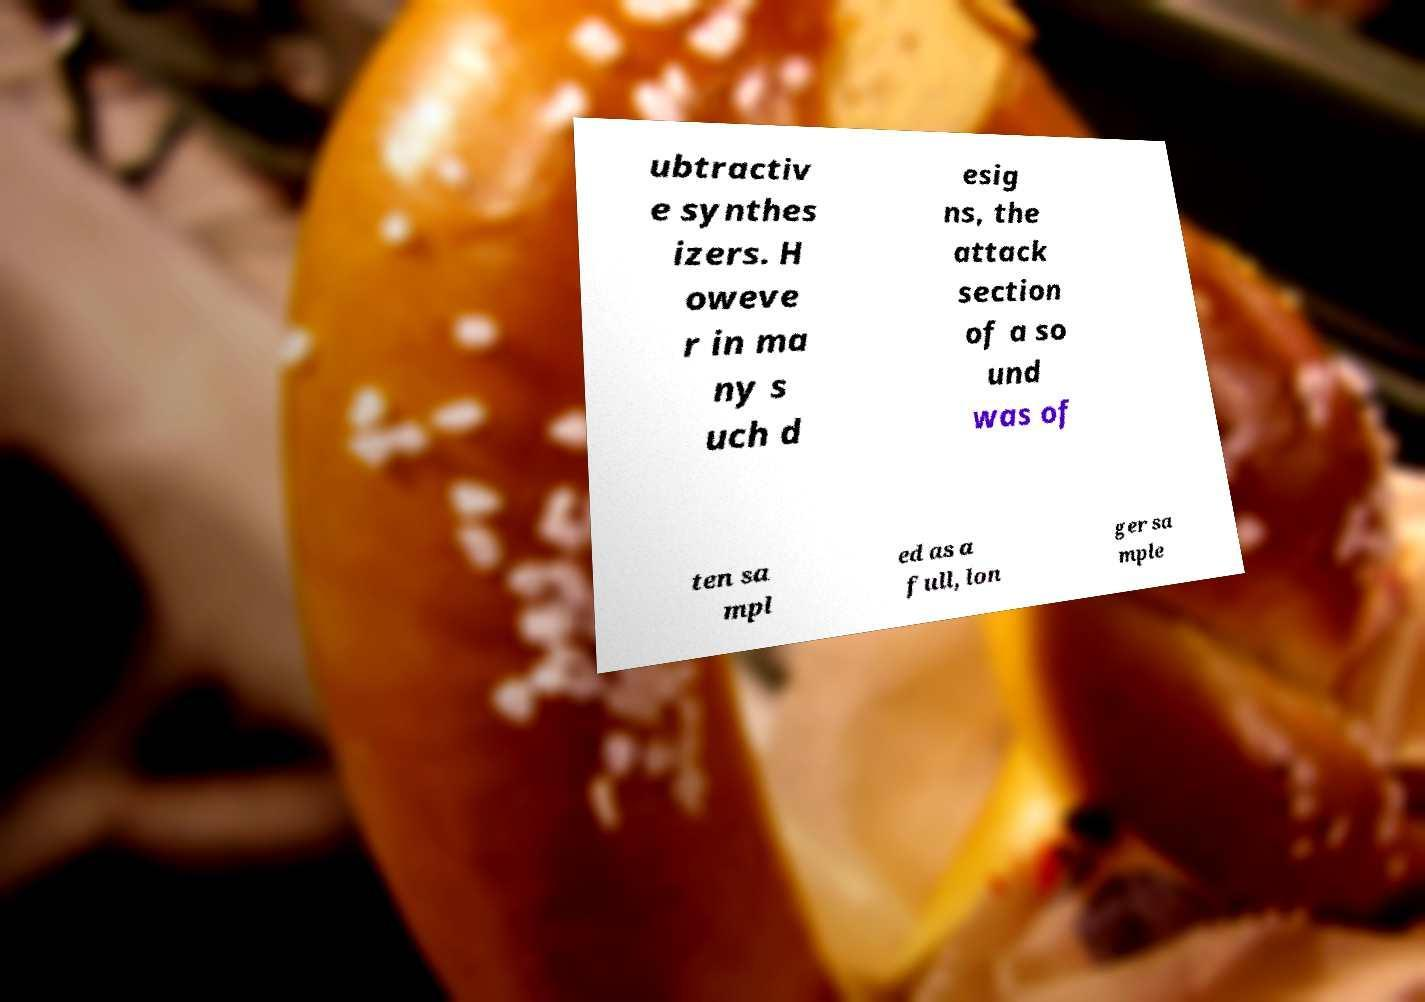Can you read and provide the text displayed in the image?This photo seems to have some interesting text. Can you extract and type it out for me? ubtractiv e synthes izers. H oweve r in ma ny s uch d esig ns, the attack section of a so und was of ten sa mpl ed as a full, lon ger sa mple 